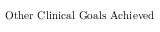<formula> <loc_0><loc_0><loc_500><loc_500>O t h e r C l i n i c a l G o a l s A c h i e v e d</formula> 